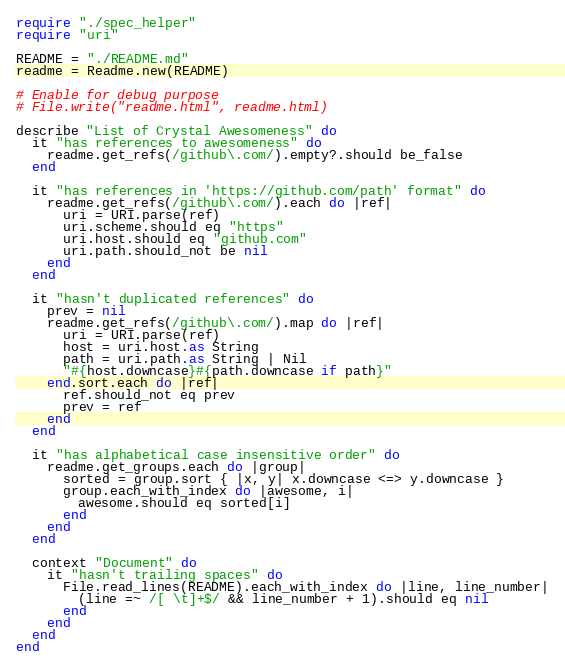Convert code to text. <code><loc_0><loc_0><loc_500><loc_500><_Crystal_>require "./spec_helper"
require "uri"

README = "./README.md"
readme = Readme.new(README)

# Enable for debug purpose
# File.write("readme.html", readme.html)

describe "List of Crystal Awesomeness" do
  it "has references to awesomeness" do
    readme.get_refs(/github\.com/).empty?.should be_false
  end

  it "has references in 'https://github.com/path' format" do
    readme.get_refs(/github\.com/).each do |ref|
      uri = URI.parse(ref)
      uri.scheme.should eq "https"
      uri.host.should eq "github.com"
      uri.path.should_not be nil
    end
  end

  it "hasn't duplicated references" do
    prev = nil
    readme.get_refs(/github\.com/).map do |ref|
      uri = URI.parse(ref)
      host = uri.host.as String
      path = uri.path.as String | Nil
      "#{host.downcase}#{path.downcase if path}"
    end.sort.each do |ref|
      ref.should_not eq prev
      prev = ref
    end
  end

  it "has alphabetical case insensitive order" do
    readme.get_groups.each do |group|
      sorted = group.sort { |x, y| x.downcase <=> y.downcase }
      group.each_with_index do |awesome, i|
        awesome.should eq sorted[i]
      end
    end
  end

  context "Document" do
    it "hasn't trailing spaces" do
      File.read_lines(README).each_with_index do |line, line_number|
        (line =~ /[ \t]+$/ && line_number + 1).should eq nil
      end
    end
  end
end
</code> 